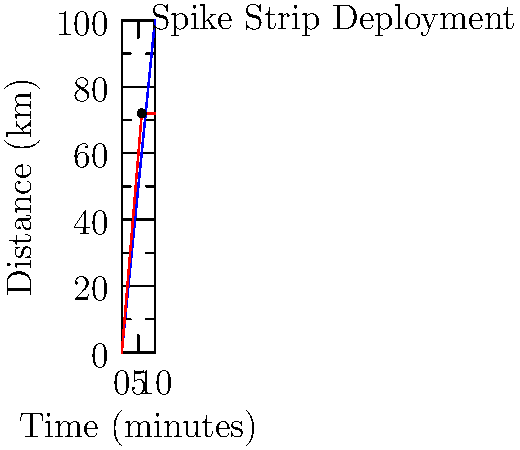Based on the distance-time graph showing a high-speed pursuit, at what time (in minutes) after the deployment of spike strips would the police vehicle catch up to the suspect vehicle, assuming the suspect's speed is reduced to 60% of its original speed after the spike strip deployment? Let's approach this step-by-step:

1) First, we need to determine the speeds of both vehicles before the spike strip deployment:
   - Police vehicle: $\frac{60 \text{ km}}{6 \text{ min}} = 10 \text{ km/min}$
   - Suspect vehicle: $\frac{72 \text{ km}}{6 \text{ min}} = 12 \text{ km/min}$

2) After the spike strip deployment at 6 minutes:
   - Police vehicle speed remains constant at 10 km/min
   - Suspect vehicle speed reduces to 60% of 12 km/min: $12 * 0.6 = 7.2 \text{ km/min}$

3) Let's define $t$ as the time in minutes after the spike strip deployment when the police catch up.

4) We can set up an equation:
   Distance traveled by police = Distance traveled by suspect
   $10(t+6) = 72 + 7.2t$

5) Solve the equation:
   $10t + 60 = 72 + 7.2t$
   $2.8t = 12$
   $t = \frac{12}{2.8} = 4.29 \text{ minutes}$

6) Therefore, the police vehicle will catch up to the suspect vehicle approximately 4.29 minutes after the spike strip deployment.

7) Total time from the start of the pursuit: $6 + 4.29 = 10.29 \text{ minutes}$
Answer: 10.29 minutes 